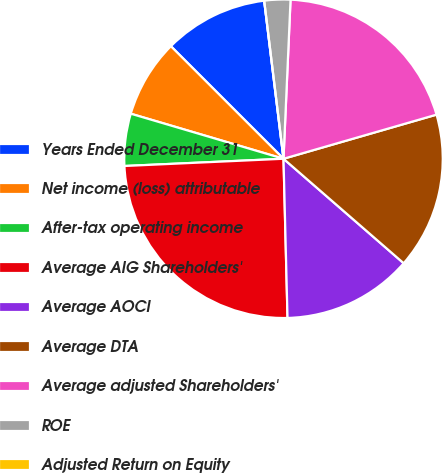Convert chart to OTSL. <chart><loc_0><loc_0><loc_500><loc_500><pie_chart><fcel>Years Ended December 31<fcel>Net income (loss) attributable<fcel>After-tax operating income<fcel>Average AIG Shareholders'<fcel>Average AOCI<fcel>Average DTA<fcel>Average adjusted Shareholders'<fcel>ROE<fcel>Adjusted Return on Equity<nl><fcel>10.57%<fcel>7.93%<fcel>5.29%<fcel>24.68%<fcel>13.21%<fcel>15.86%<fcel>19.83%<fcel>2.64%<fcel>0.0%<nl></chart> 